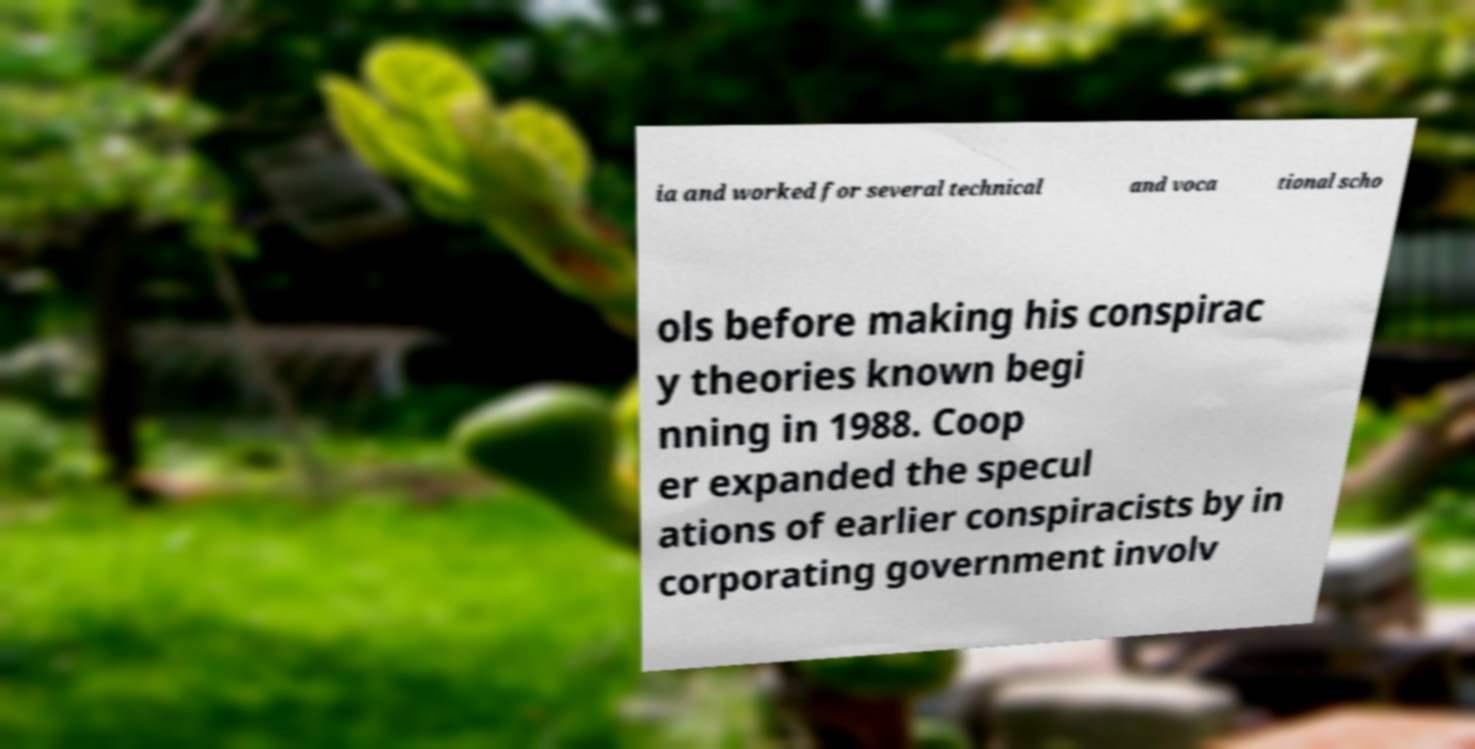For documentation purposes, I need the text within this image transcribed. Could you provide that? ia and worked for several technical and voca tional scho ols before making his conspirac y theories known begi nning in 1988. Coop er expanded the specul ations of earlier conspiracists by in corporating government involv 